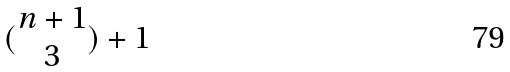<formula> <loc_0><loc_0><loc_500><loc_500>( \begin{matrix} n + 1 \\ 3 \end{matrix} ) + 1</formula> 